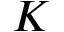Convert formula to latex. <formula><loc_0><loc_0><loc_500><loc_500>K</formula> 